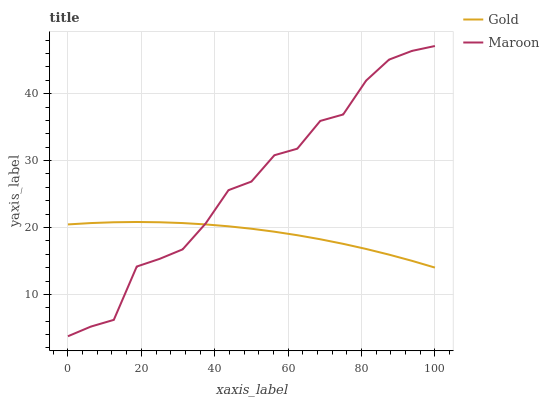Does Gold have the minimum area under the curve?
Answer yes or no. Yes. Does Maroon have the maximum area under the curve?
Answer yes or no. Yes. Does Gold have the maximum area under the curve?
Answer yes or no. No. Is Gold the smoothest?
Answer yes or no. Yes. Is Maroon the roughest?
Answer yes or no. Yes. Is Gold the roughest?
Answer yes or no. No. Does Maroon have the lowest value?
Answer yes or no. Yes. Does Gold have the lowest value?
Answer yes or no. No. Does Maroon have the highest value?
Answer yes or no. Yes. Does Gold have the highest value?
Answer yes or no. No. Does Maroon intersect Gold?
Answer yes or no. Yes. Is Maroon less than Gold?
Answer yes or no. No. Is Maroon greater than Gold?
Answer yes or no. No. 